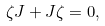Convert formula to latex. <formula><loc_0><loc_0><loc_500><loc_500>\zeta J + J \zeta = 0 ,</formula> 